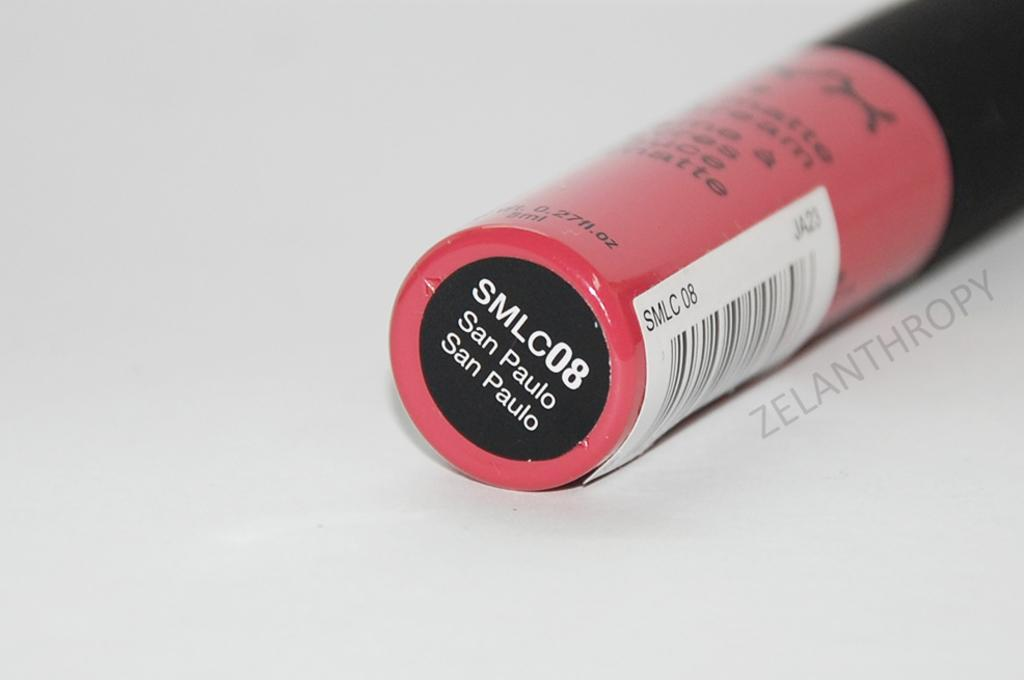What is the color of the surface in the image? The surface in the image is gray. What can be found on the right side of the image? There is an object with text on the right side of the image. Where is the dock located in the image? There is no dock present in the image. What type of drum is visible on the gray surface? There is no drum visible on the gray surface in the image. 